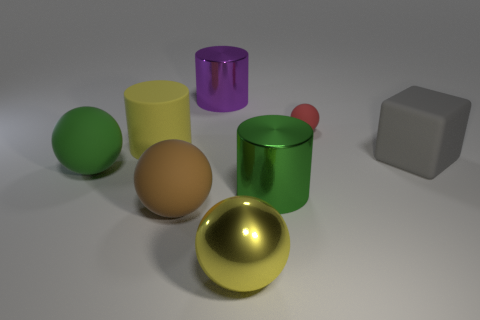What number of matte objects are either cylinders or large brown balls?
Your answer should be compact. 2. Do the purple cylinder and the red object have the same material?
Your response must be concise. No. What is the material of the thing right of the matte thing that is behind the yellow matte thing?
Provide a succinct answer. Rubber. What number of large objects are brown rubber balls or shiny cylinders?
Provide a succinct answer. 3. The yellow matte thing has what size?
Your response must be concise. Large. Is the number of large purple metallic cylinders right of the big yellow shiny thing greater than the number of yellow metallic spheres?
Offer a terse response. No. Is the number of large spheres that are right of the large purple thing the same as the number of gray matte cubes that are on the left side of the small object?
Keep it short and to the point. No. There is a matte sphere that is both right of the large matte cylinder and behind the large brown object; what is its color?
Your answer should be compact. Red. Are there any other things that are the same size as the brown ball?
Your answer should be compact. Yes. Are there more metal objects that are behind the big yellow shiny thing than large gray rubber blocks in front of the big brown matte sphere?
Your answer should be compact. Yes. 